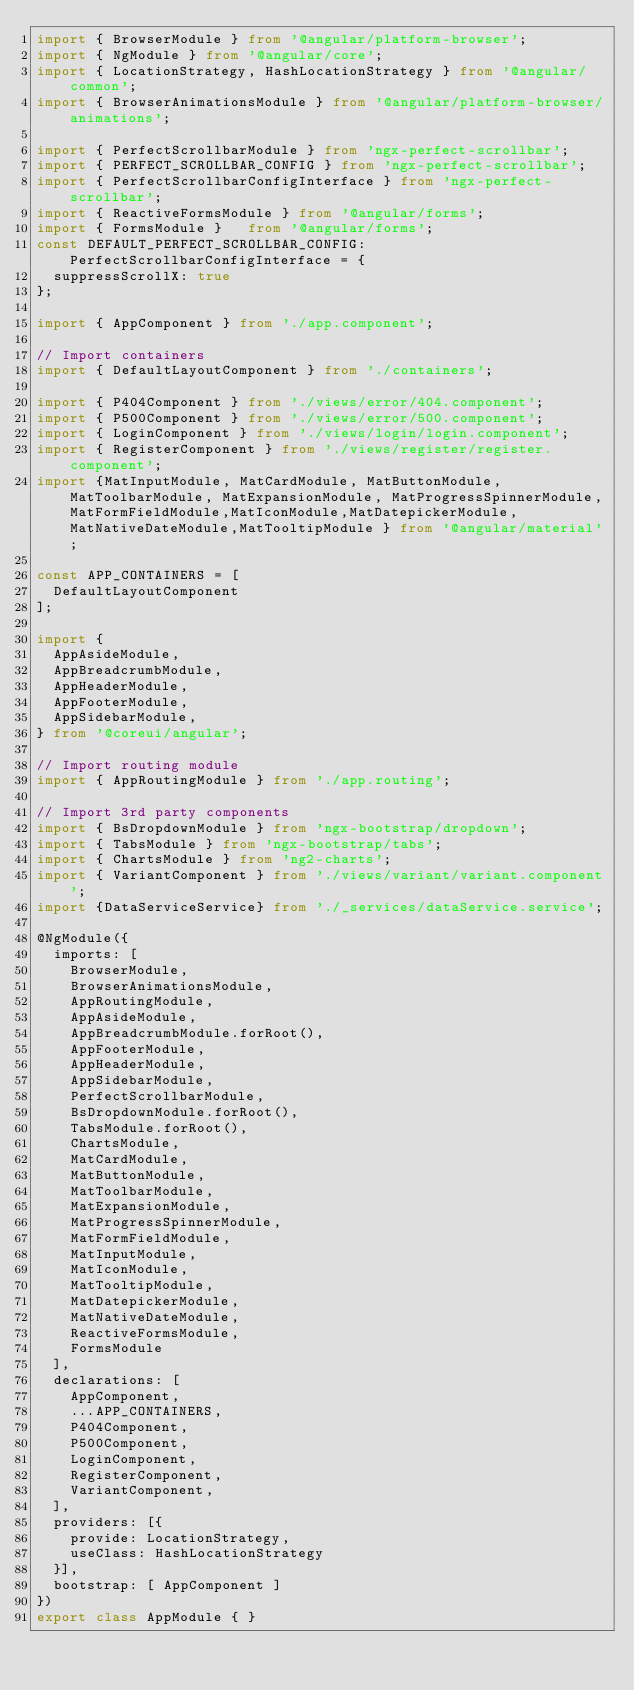Convert code to text. <code><loc_0><loc_0><loc_500><loc_500><_TypeScript_>import { BrowserModule } from '@angular/platform-browser';
import { NgModule } from '@angular/core';
import { LocationStrategy, HashLocationStrategy } from '@angular/common';
import { BrowserAnimationsModule } from '@angular/platform-browser/animations';

import { PerfectScrollbarModule } from 'ngx-perfect-scrollbar';
import { PERFECT_SCROLLBAR_CONFIG } from 'ngx-perfect-scrollbar';
import { PerfectScrollbarConfigInterface } from 'ngx-perfect-scrollbar';
import { ReactiveFormsModule } from '@angular/forms';
import { FormsModule }   from '@angular/forms';
const DEFAULT_PERFECT_SCROLLBAR_CONFIG: PerfectScrollbarConfigInterface = {
  suppressScrollX: true
};

import { AppComponent } from './app.component';

// Import containers
import { DefaultLayoutComponent } from './containers';

import { P404Component } from './views/error/404.component';
import { P500Component } from './views/error/500.component';
import { LoginComponent } from './views/login/login.component';
import { RegisterComponent } from './views/register/register.component';
import {MatInputModule, MatCardModule, MatButtonModule, MatToolbarModule, MatExpansionModule, MatProgressSpinnerModule,MatFormFieldModule,MatIconModule,MatDatepickerModule,MatNativeDateModule,MatTooltipModule } from '@angular/material';

const APP_CONTAINERS = [
  DefaultLayoutComponent
];

import {
  AppAsideModule,
  AppBreadcrumbModule,
  AppHeaderModule,
  AppFooterModule,
  AppSidebarModule,
} from '@coreui/angular';

// Import routing module
import { AppRoutingModule } from './app.routing';

// Import 3rd party components
import { BsDropdownModule } from 'ngx-bootstrap/dropdown';
import { TabsModule } from 'ngx-bootstrap/tabs';
import { ChartsModule } from 'ng2-charts';
import { VariantComponent } from './views/variant/variant.component';
import {DataServiceService} from './_services/dataService.service';

@NgModule({
  imports: [
    BrowserModule,
    BrowserAnimationsModule,
    AppRoutingModule,
    AppAsideModule,
    AppBreadcrumbModule.forRoot(),
    AppFooterModule,
    AppHeaderModule,
    AppSidebarModule,
    PerfectScrollbarModule,
    BsDropdownModule.forRoot(),
    TabsModule.forRoot(),
    ChartsModule,
    MatCardModule,
    MatButtonModule,
    MatToolbarModule,
    MatExpansionModule,
    MatProgressSpinnerModule,
    MatFormFieldModule,
    MatInputModule,
    MatIconModule,
    MatTooltipModule,
    MatDatepickerModule,
    MatNativeDateModule,
    ReactiveFormsModule,
    FormsModule
  ],
  declarations: [
    AppComponent,
    ...APP_CONTAINERS,
    P404Component,
    P500Component,
    LoginComponent,
    RegisterComponent,
    VariantComponent,
  ],
  providers: [{
    provide: LocationStrategy,
    useClass: HashLocationStrategy
  }],
  bootstrap: [ AppComponent ]
})
export class AppModule { }
</code> 